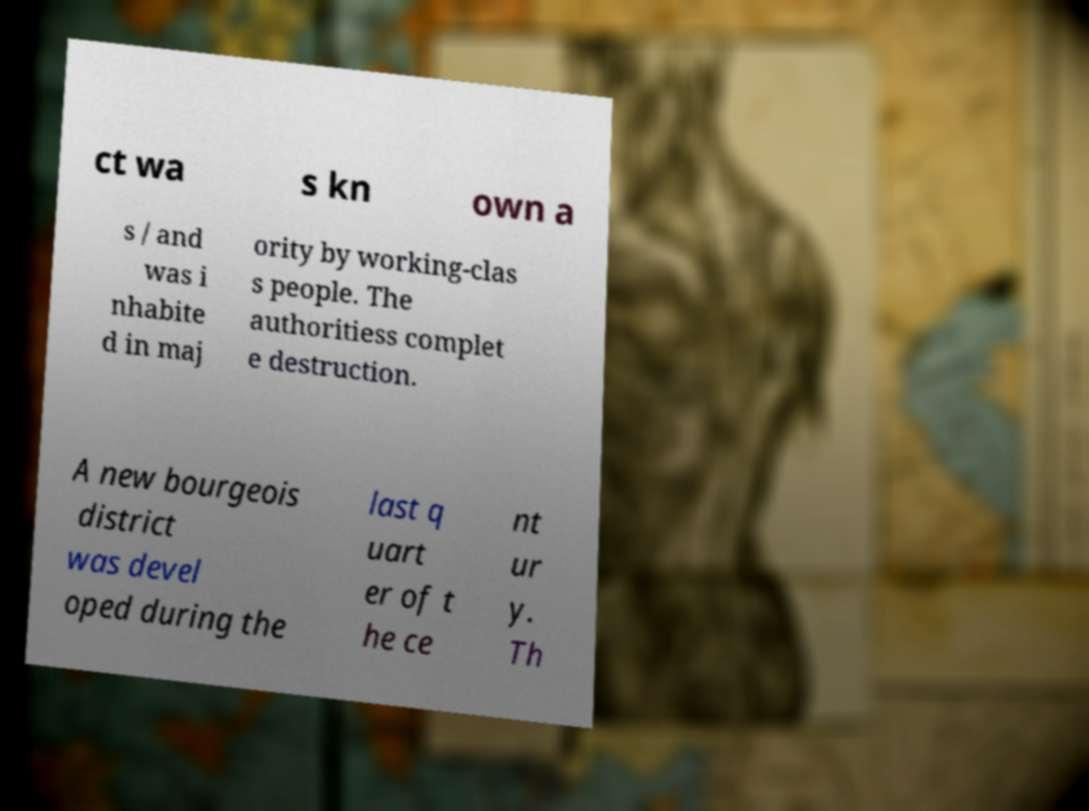What messages or text are displayed in this image? I need them in a readable, typed format. ct wa s kn own a s / and was i nhabite d in maj ority by working-clas s people. The authoritiess complet e destruction. A new bourgeois district was devel oped during the last q uart er of t he ce nt ur y. Th 